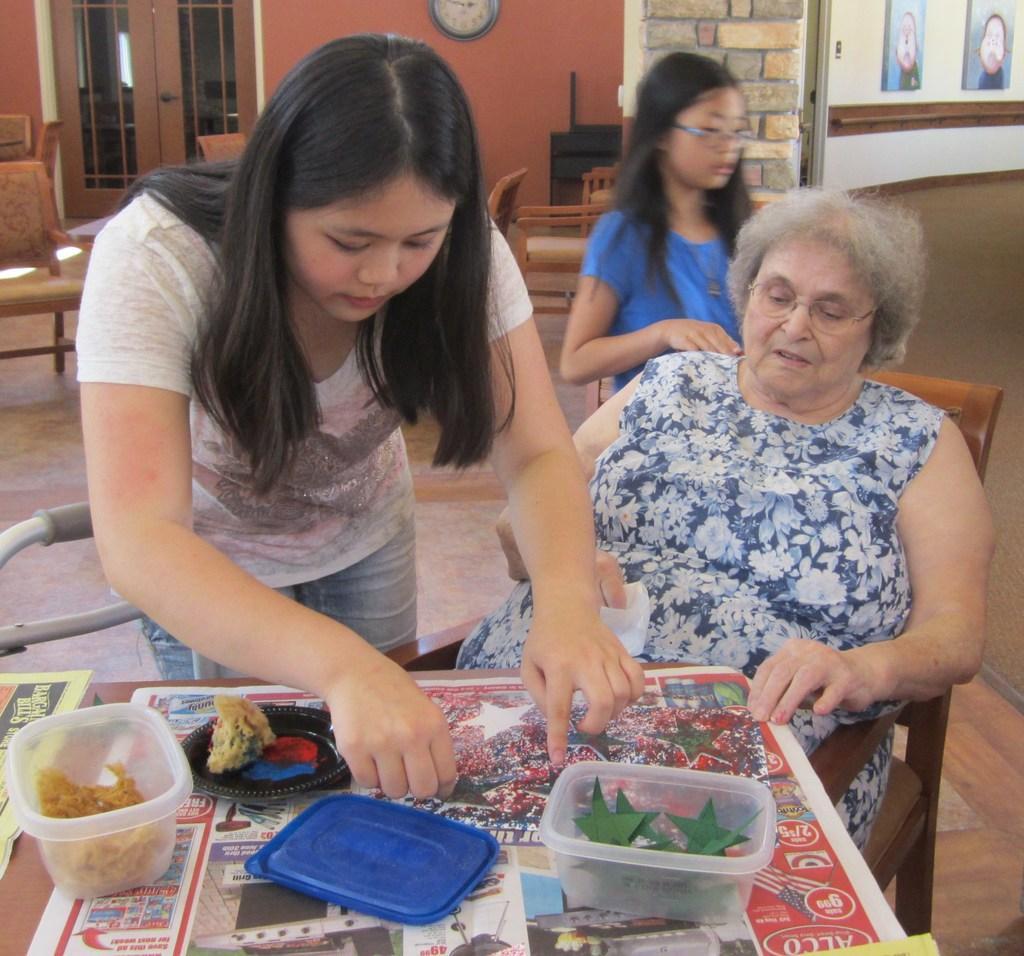Describe this image in one or two sentences. In the center of the image we can see a lady standing and placing objects on the table, next to her there is a lady sitting. In the background there is a girl. At the bottom there is a table and we can see boxes, papers, lids, decors and some objects placed on the table. There are chairs. On the left there is a window. We can see frames and a clock placed on the walls. 